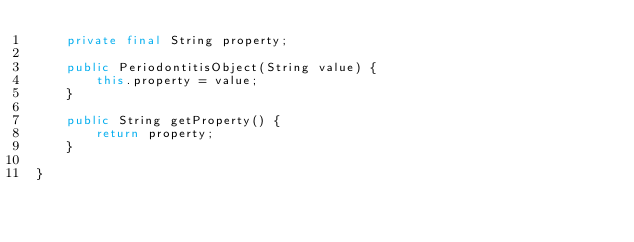<code> <loc_0><loc_0><loc_500><loc_500><_Java_>    private final String property;

    public PeriodontitisObject(String value) {
        this.property = value;
    }

    public String getProperty() {
        return property;
    }

}
</code> 